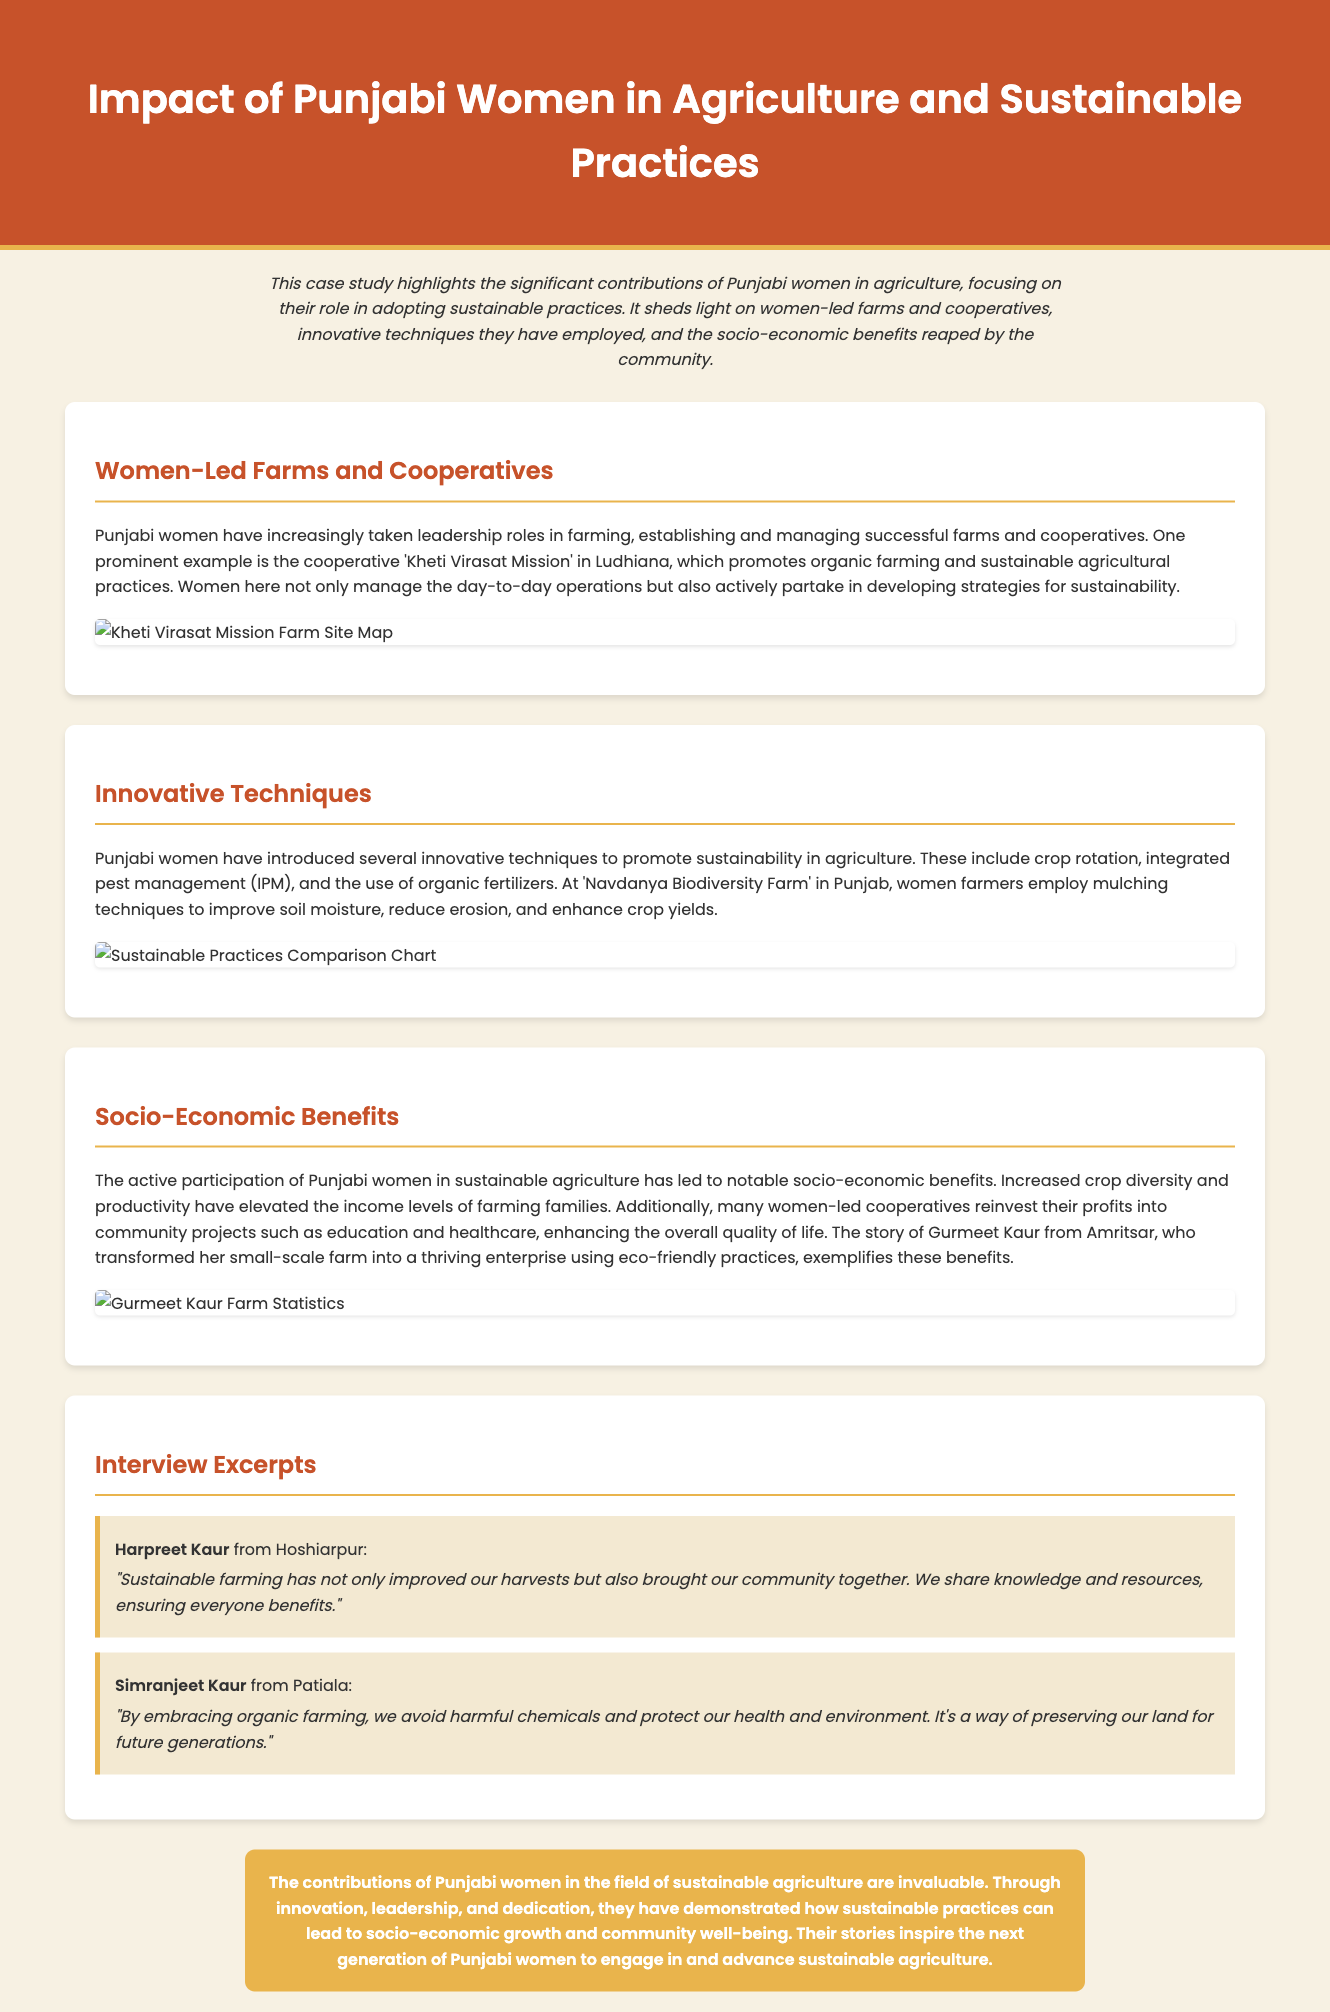What is the name of the cooperative mentioned in the case study? The cooperative 'Kheti Virasat Mission' in Ludhiana is specifically highlighted in the document as a women-led initiative promoting sustainable agriculture.
Answer: Kheti Virasat Mission Which innovative technique is employed at 'Navdanya Biodiversity Farm'? The document states that women farmers at this farm employ mulching techniques to improve soil moisture, reduce erosion, and enhance crop yields.
Answer: Mulching What significant socio-economic benefit is highlighted regarding women's participation in agriculture? The document notes that increased crop diversity and productivity have elevated the income levels of farming families, showcasing the economic impact of women's roles in sustainable practices.
Answer: Elevated income levels Who is the woman from Amritsar mentioned in the socio-economic benefits section? The document includes the story of Gurmeet Kaur from Amritsar, illustrating her success through eco-friendly farming practices.
Answer: Gurmeet Kaur What type of farming do Punjabi women embrace to protect their health and environment? Simranjeet Kaur emphasizes embracing organic farming as a way to avoid harmful chemicals and maintain health and environmental safety.
Answer: Organic farming 